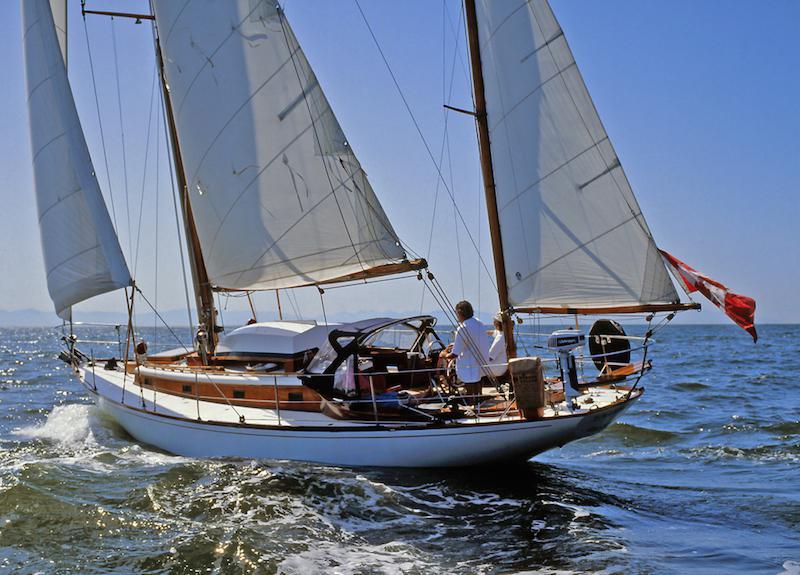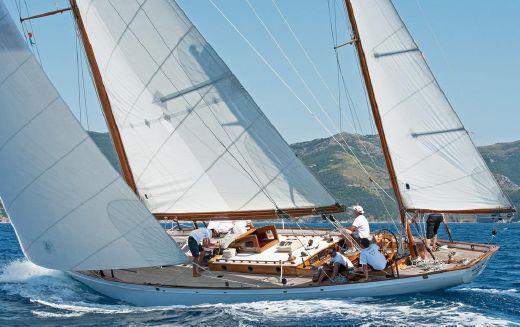The first image is the image on the left, the second image is the image on the right. For the images displayed, is the sentence "All sailboats have three sails unfurled." factually correct? Answer yes or no. Yes. The first image is the image on the left, the second image is the image on the right. Analyze the images presented: Is the assertion "There is visible land in the background of at least one image." valid? Answer yes or no. Yes. 